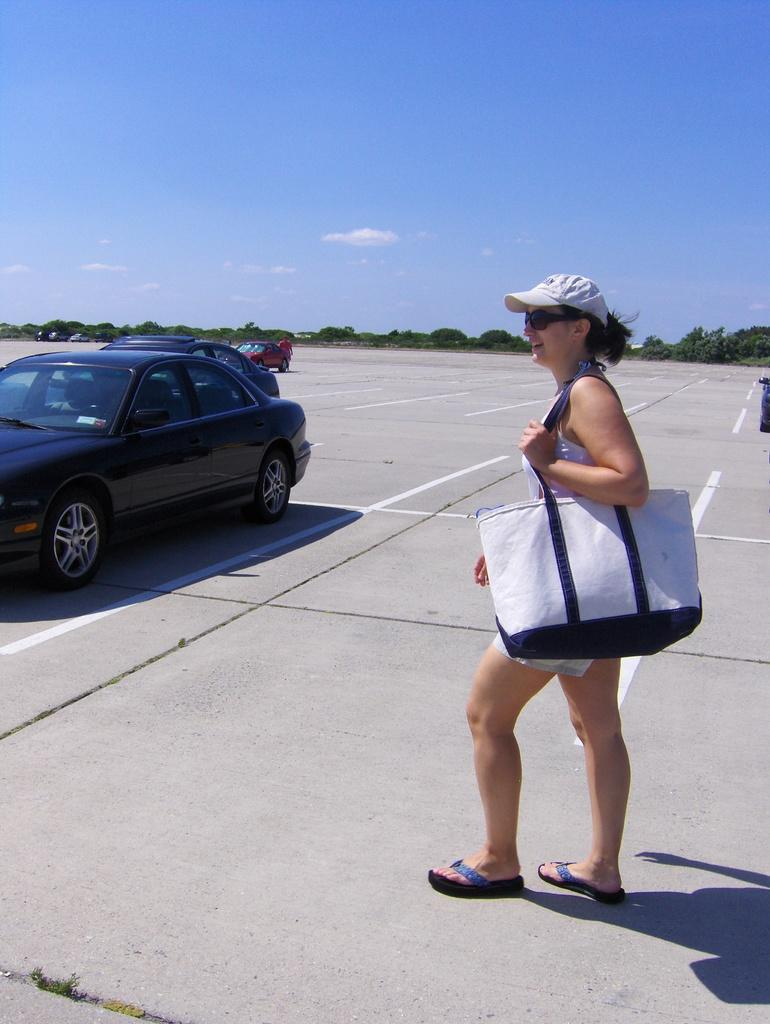What is the woman wearing on her head in the image? The woman is wearing a cap in the image. What is the woman carrying in her hand? The woman is carrying a bag in the image. What is the woman doing in the image? The woman is walking, as indicated by the movement in her legs. What can be seen on the road in the image? There are vehicles on the road in the image. What is visible in the distance in the image? There are trees in the distance in the image. What color is the sky in the image? The sky is blue in the image. What type of sweater is the woman wearing on stage in the image? There is no stage or sweater present in the image; the woman is wearing a cap and walking on a road. 